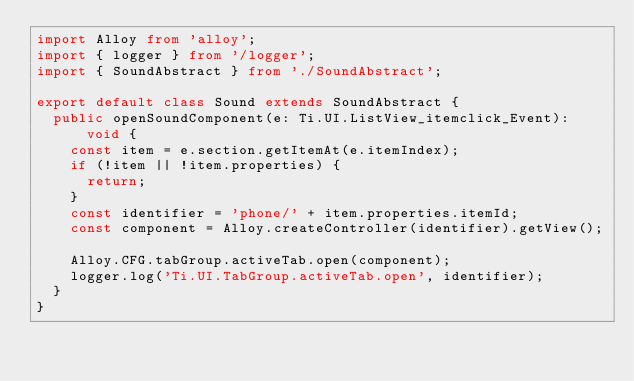<code> <loc_0><loc_0><loc_500><loc_500><_TypeScript_>import Alloy from 'alloy';
import { logger } from '/logger';
import { SoundAbstract } from './SoundAbstract';

export default class Sound extends SoundAbstract {
	public openSoundComponent(e: Ti.UI.ListView_itemclick_Event): void {
		const item = e.section.getItemAt(e.itemIndex);
		if (!item || !item.properties) {
			return;
		}
		const identifier = 'phone/' + item.properties.itemId;
		const component = Alloy.createController(identifier).getView();

		Alloy.CFG.tabGroup.activeTab.open(component);
		logger.log('Ti.UI.TabGroup.activeTab.open', identifier);
	}
}
</code> 